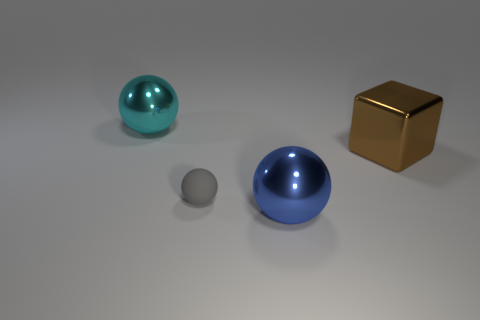Subtract all large spheres. How many spheres are left? 1 Add 3 large shiny things. How many objects exist? 7 Subtract all balls. How many objects are left? 1 Subtract all brown spheres. Subtract all gray cubes. How many spheres are left? 3 Subtract 0 red spheres. How many objects are left? 4 Subtract all large blue metal spheres. Subtract all blue matte things. How many objects are left? 3 Add 3 metallic spheres. How many metallic spheres are left? 5 Add 2 tiny gray rubber balls. How many tiny gray rubber balls exist? 3 